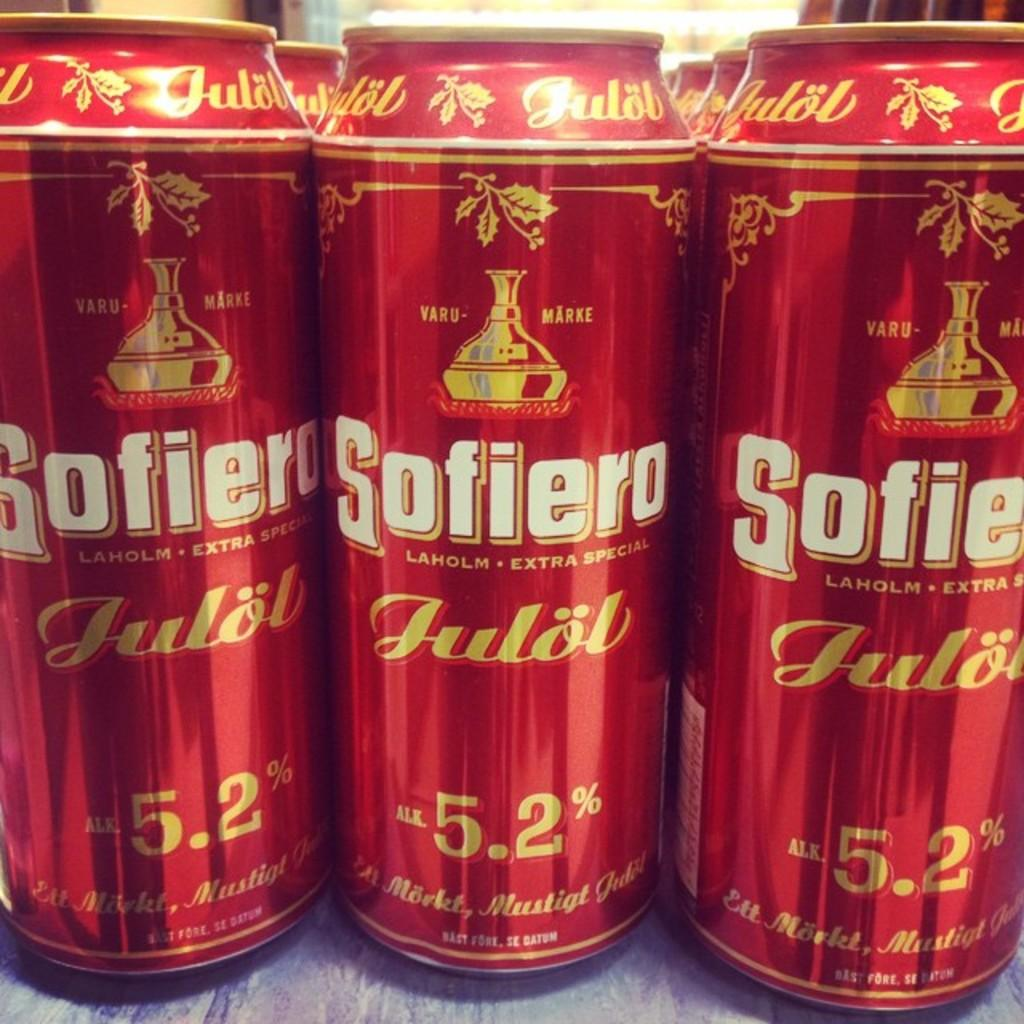Provide a one-sentence caption for the provided image. A row of beer cans that say Sofiero Laholm Extra Special. 